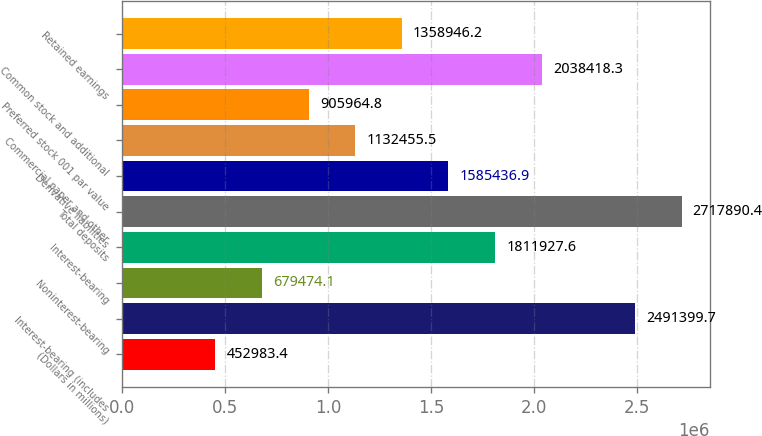Convert chart to OTSL. <chart><loc_0><loc_0><loc_500><loc_500><bar_chart><fcel>(Dollars in millions)<fcel>Interest-bearing (includes<fcel>Noninterest-bearing<fcel>Interest-bearing<fcel>Total deposits<fcel>Derivative liabilities<fcel>Commercial paper and other<fcel>Preferred stock 001 par value<fcel>Common stock and additional<fcel>Retained earnings<nl><fcel>452983<fcel>2.4914e+06<fcel>679474<fcel>1.81193e+06<fcel>2.71789e+06<fcel>1.58544e+06<fcel>1.13246e+06<fcel>905965<fcel>2.03842e+06<fcel>1.35895e+06<nl></chart> 